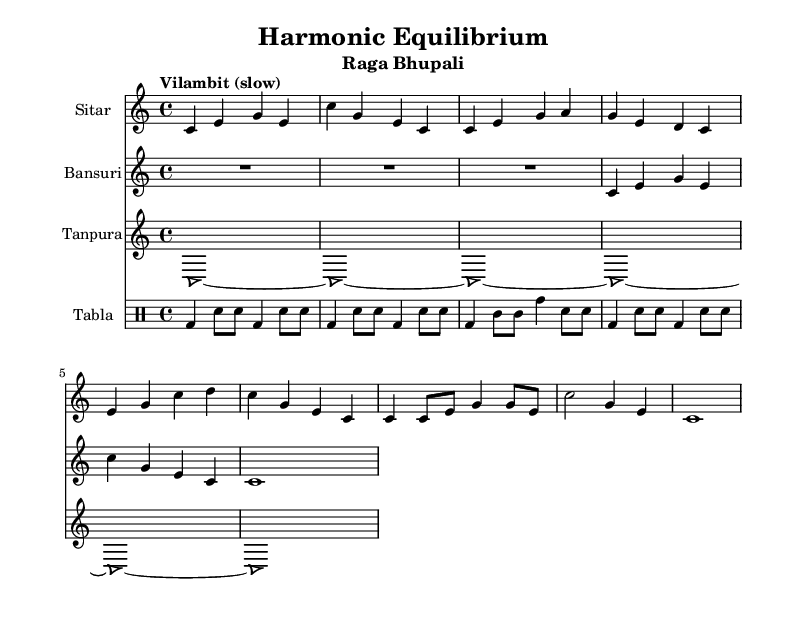What is the key signature of this music? The key signature is identified by the absence of any sharps or flats, which indicates that it is in C major.
Answer: C major What is the time signature of this music? The time signature is indicated at the beginning of the score, showing that it is in 4/4 time, which means there are four beats in each measure.
Answer: 4/4 What is the tempo marking for this piece? The tempo marking is located right below the clef signs and it states "Vilambit (slow)," indicating that the piece should be played at a slow pace.
Answer: Vilambit How many instruments are featured in this music? By examining the score, we can see separate staves for the sitar, bansuri, tanpura, and tabla, totaling four distinct instruments featured in the composition.
Answer: Four Which raga is represented in this score? The title at the top of the sheet music specifies "Raga Bhupali," which indicates the specific raga being performed.
Answer: Raga Bhupali What type of musical notation is used for the tabla? The tabla part uses drum notation, which is typically identified by specific symbols for the different drum strokes, as seen in the given section for tabla.
Answer: Drum notation How does the sitar melody relate to the tanpura drone? The sitar's melody aligns with the tanpura's drone notes, creating a harmonic foundation. The sitar often plays notes that complement the constant drone established by the tanpura, providing a sense of stability and harmony within the piece.
Answer: Harmonic foundation 